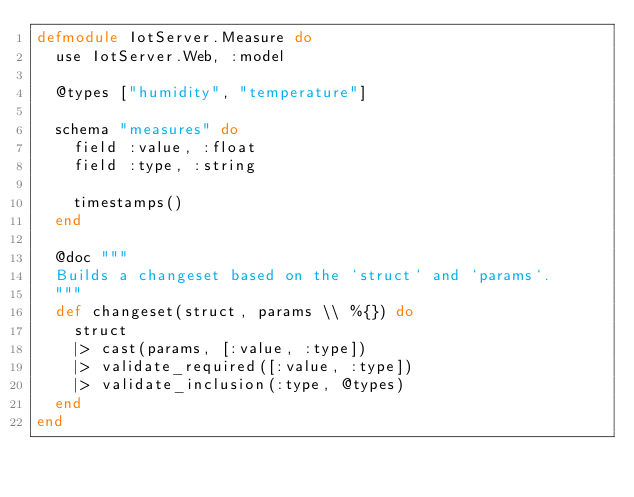<code> <loc_0><loc_0><loc_500><loc_500><_Elixir_>defmodule IotServer.Measure do
  use IotServer.Web, :model

  @types ["humidity", "temperature"]

  schema "measures" do
    field :value, :float
    field :type, :string

    timestamps()
  end

  @doc """
  Builds a changeset based on the `struct` and `params`.
  """
  def changeset(struct, params \\ %{}) do
    struct
    |> cast(params, [:value, :type])
    |> validate_required([:value, :type])
    |> validate_inclusion(:type, @types)
  end
end
</code> 